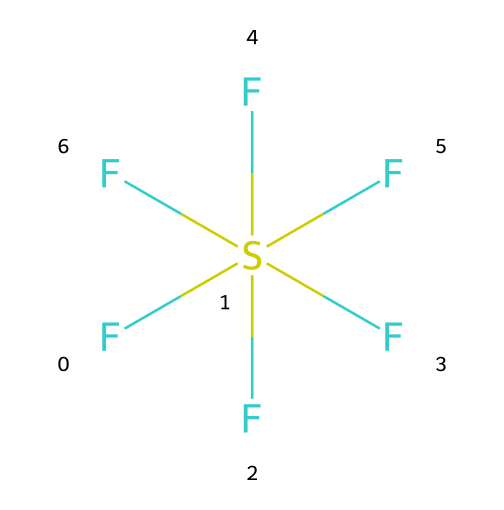What is the molecular formula of sulfur hexafluoride? By counting the number of sulfur atoms and fluorine atoms in the structure represented by the SMILES notation, we see there is one sulfur atom and six fluorine atoms. Thus, the molecular formula is SF6.
Answer: SF6 How many fluorine atoms are attached to the sulfur atom? The structure clearly indicates that there are six fluorine atoms bonded directly to one sulfur atom.
Answer: six What is the hybridization of the sulfur atom in this compound? The sulfur atom in sulfur hexafluoride has six bonds (to fluorine) and conforms to an octahedral geometry, which corresponds to sp3d2 hybridization.
Answer: sp3d2 What type of bonds are present in sulfur hexafluoride? In this compound, the bonds between the sulfur and fluorine atoms are single covalent bonds, as indicated by the simple direct connections in the chemical structure.
Answer: single covalent bonds What is unique about hypervalent compounds, like sulfur hexafluoride? Hypervalent compounds, such as sulfur hexafluoride, can accommodate more than eight electrons in their valence shell, which allows them to form more bonds than typical octet rule compounds.
Answer: more than eight electrons What is the primary application of sulfur hexafluoride? Sulfur hexafluoride is primarily used as an insulating gas in electrical equipment and circuit breakers due to its excellent dielectric properties and high density.
Answer: insulating gas in electrical equipment 